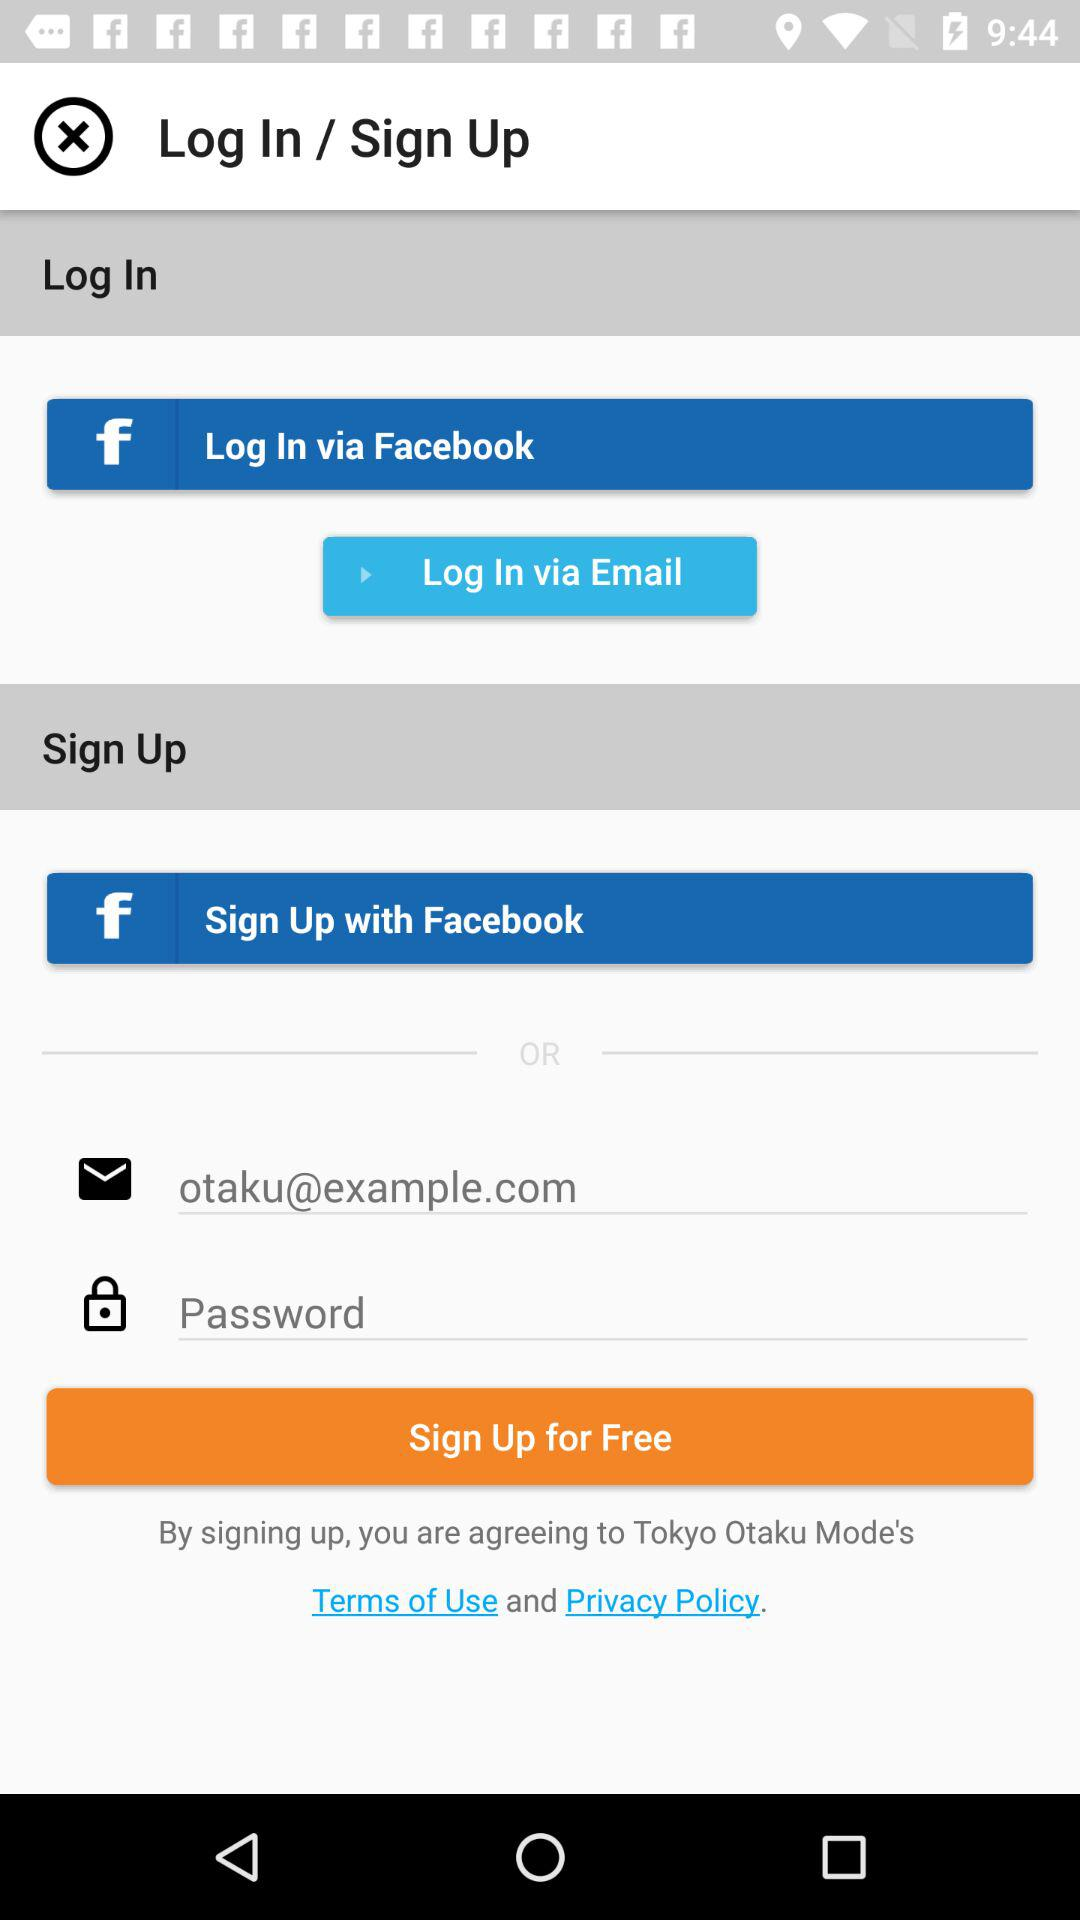How many sign up options are available?
Answer the question using a single word or phrase. 2 